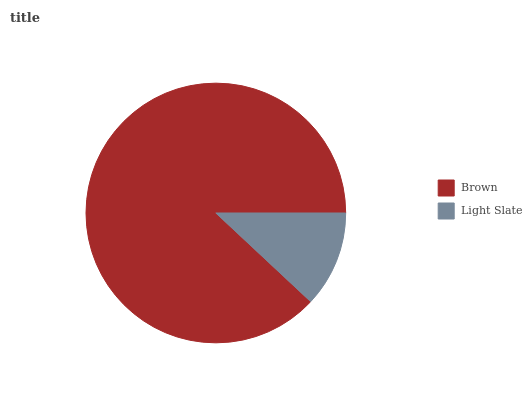Is Light Slate the minimum?
Answer yes or no. Yes. Is Brown the maximum?
Answer yes or no. Yes. Is Light Slate the maximum?
Answer yes or no. No. Is Brown greater than Light Slate?
Answer yes or no. Yes. Is Light Slate less than Brown?
Answer yes or no. Yes. Is Light Slate greater than Brown?
Answer yes or no. No. Is Brown less than Light Slate?
Answer yes or no. No. Is Brown the high median?
Answer yes or no. Yes. Is Light Slate the low median?
Answer yes or no. Yes. Is Light Slate the high median?
Answer yes or no. No. Is Brown the low median?
Answer yes or no. No. 